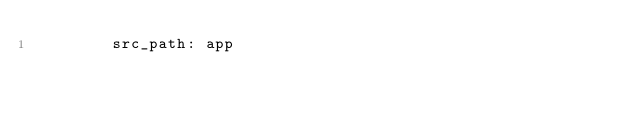Convert code to text. <code><loc_0><loc_0><loc_500><loc_500><_YAML_>        src_path: app</code> 